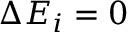<formula> <loc_0><loc_0><loc_500><loc_500>\Delta E _ { i } = 0</formula> 